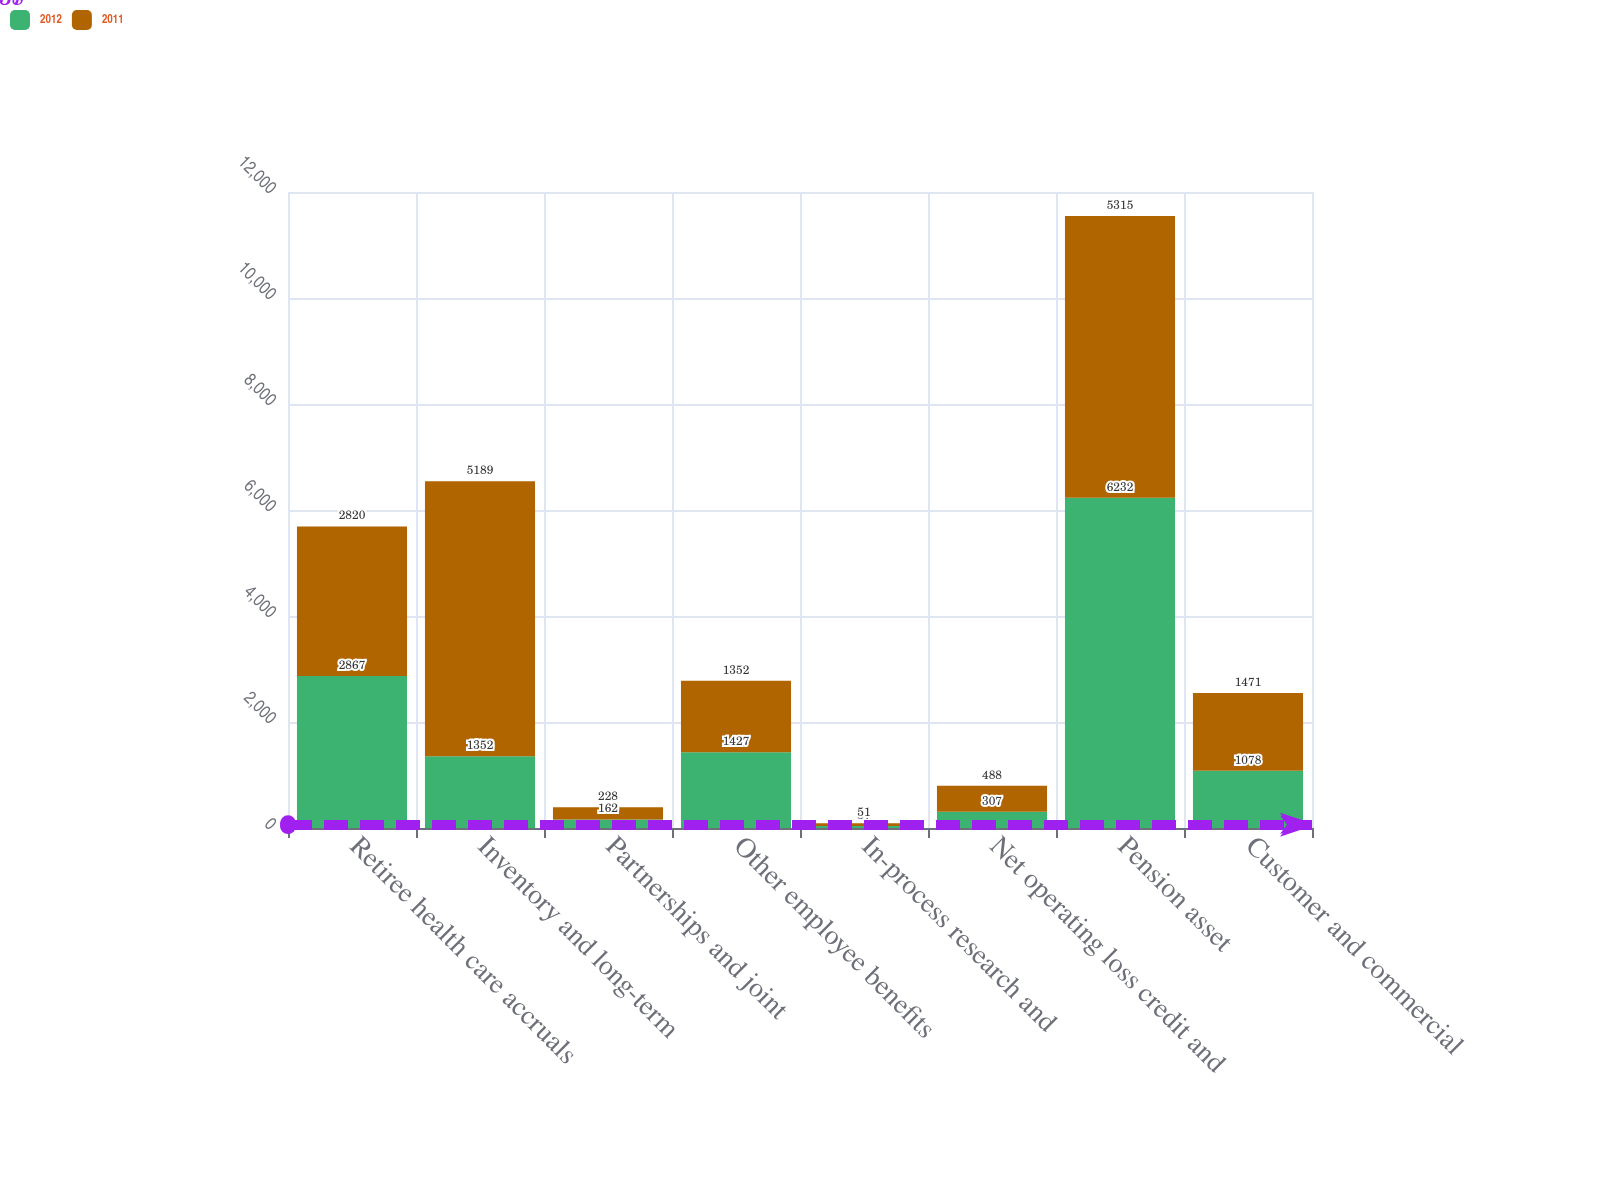Convert chart to OTSL. <chart><loc_0><loc_0><loc_500><loc_500><stacked_bar_chart><ecel><fcel>Retiree health care accruals<fcel>Inventory and long-term<fcel>Partnerships and joint<fcel>Other employee benefits<fcel>In-process research and<fcel>Net operating loss credit and<fcel>Pension asset<fcel>Customer and commercial<nl><fcel>2012<fcel>2867<fcel>1352<fcel>162<fcel>1427<fcel>37<fcel>307<fcel>6232<fcel>1078<nl><fcel>2011<fcel>2820<fcel>5189<fcel>228<fcel>1352<fcel>51<fcel>488<fcel>5315<fcel>1471<nl></chart> 